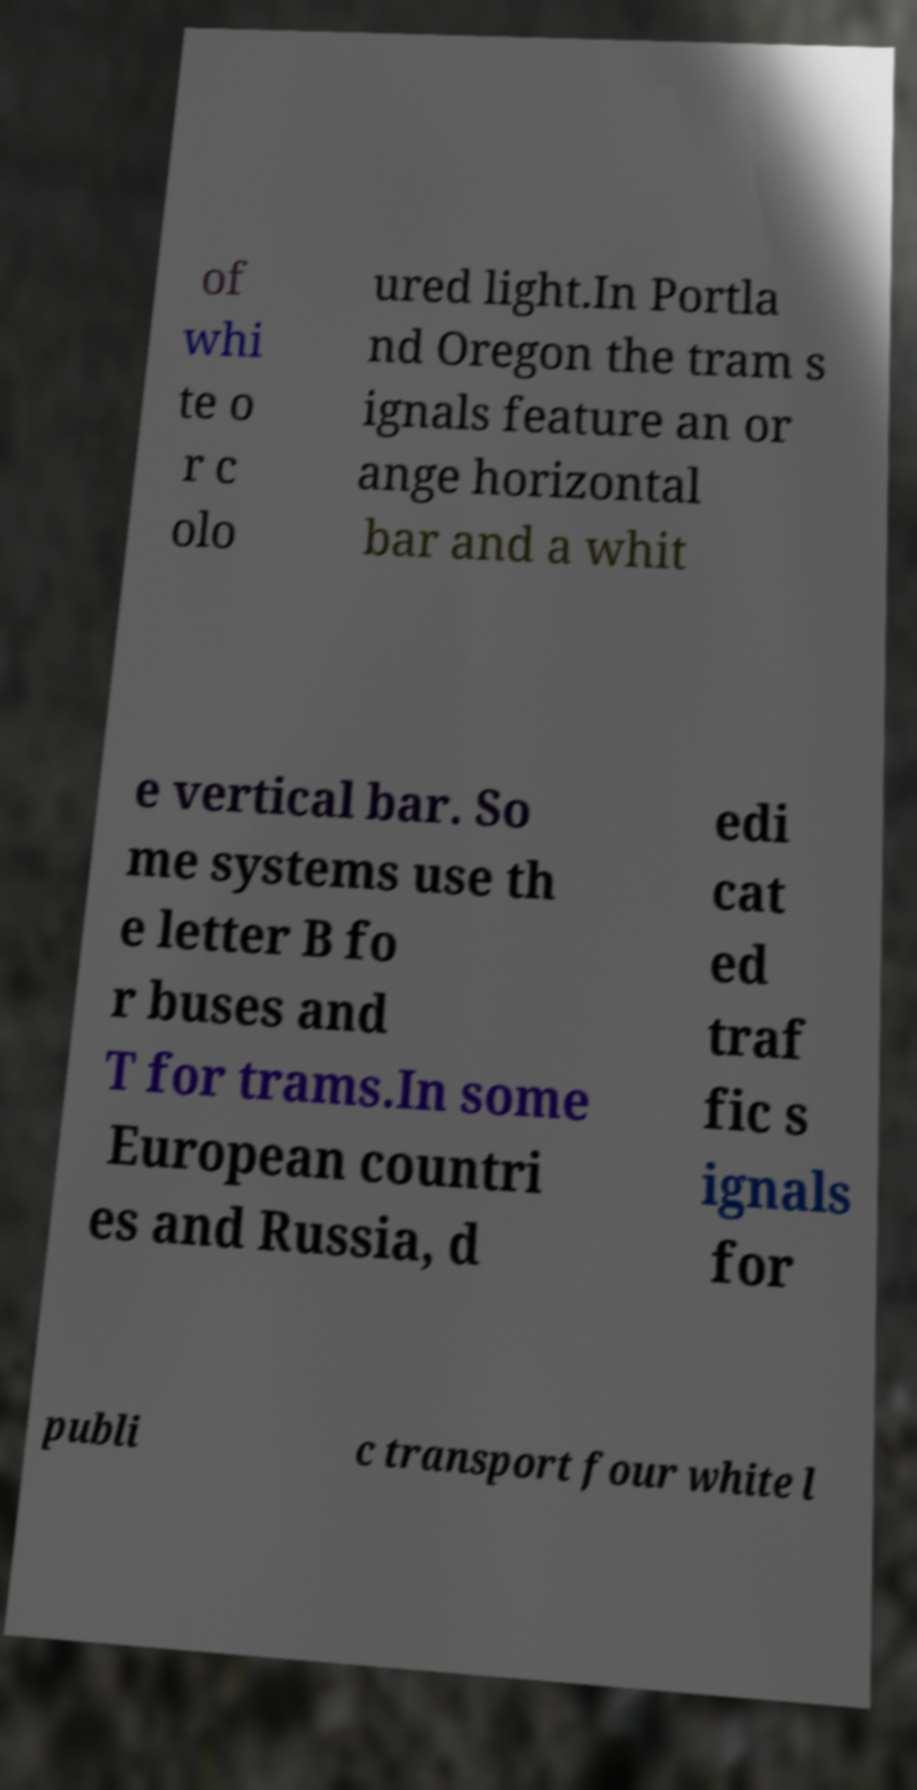Can you accurately transcribe the text from the provided image for me? of whi te o r c olo ured light.In Portla nd Oregon the tram s ignals feature an or ange horizontal bar and a whit e vertical bar. So me systems use th e letter B fo r buses and T for trams.In some European countri es and Russia, d edi cat ed traf fic s ignals for publi c transport four white l 